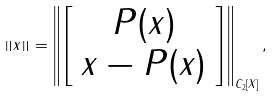<formula> <loc_0><loc_0><loc_500><loc_500>\left \| x \right \| = \left \| \left [ \begin{array} { c } P ( x ) \\ x - P ( x ) \end{array} \right ] \right \| _ { C _ { 2 } [ X ] } ,</formula> 